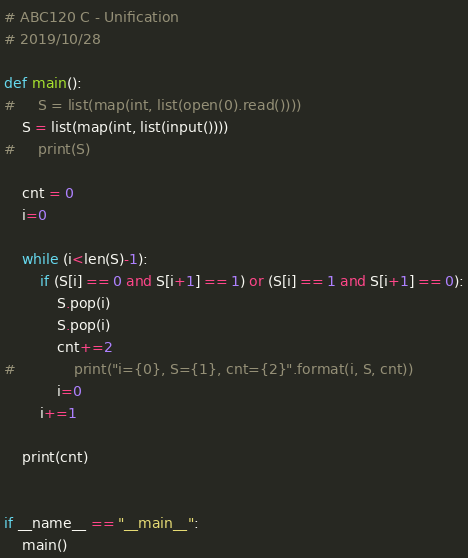Convert code to text. <code><loc_0><loc_0><loc_500><loc_500><_Python_># ABC120 C - Unification
# 2019/10/28

def main():
#     S = list(map(int, list(open(0).read())))
    S = list(map(int, list(input())))
#     print(S)
    
    cnt = 0
    i=0

    while (i<len(S)-1):
        if (S[i] == 0 and S[i+1] == 1) or (S[i] == 1 and S[i+1] == 0):
            S.pop(i)
            S.pop(i)
            cnt+=2
#             print("i={0}, S={1}, cnt={2}".format(i, S, cnt))
            i=0
        i+=1
    
    print(cnt)
    
    
if __name__ == "__main__":
    main()</code> 